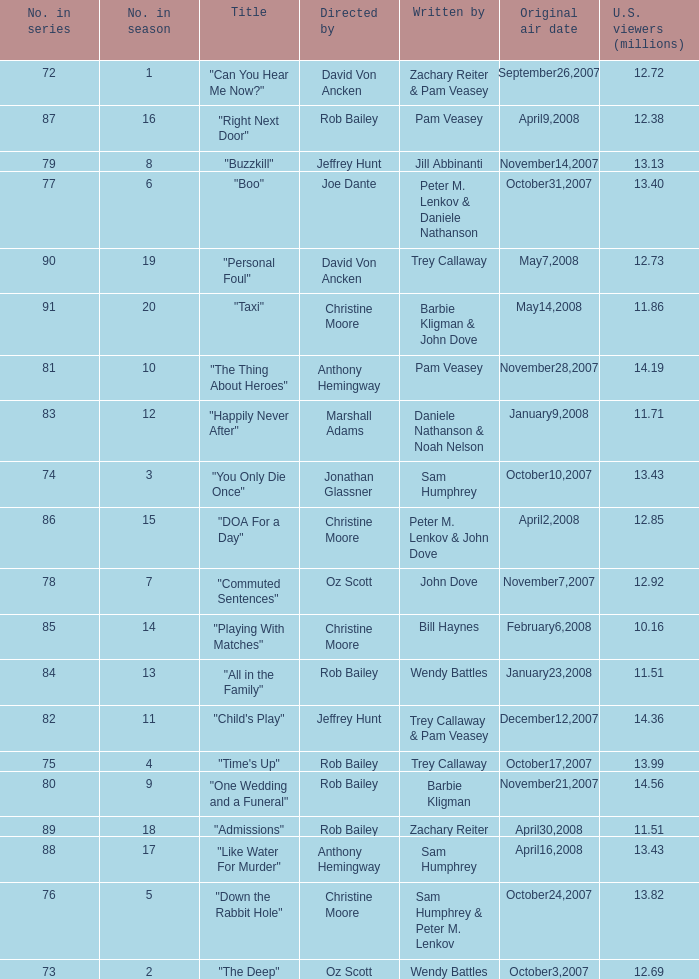How many episodes were watched by 12.72 million U.S. viewers? 1.0. 